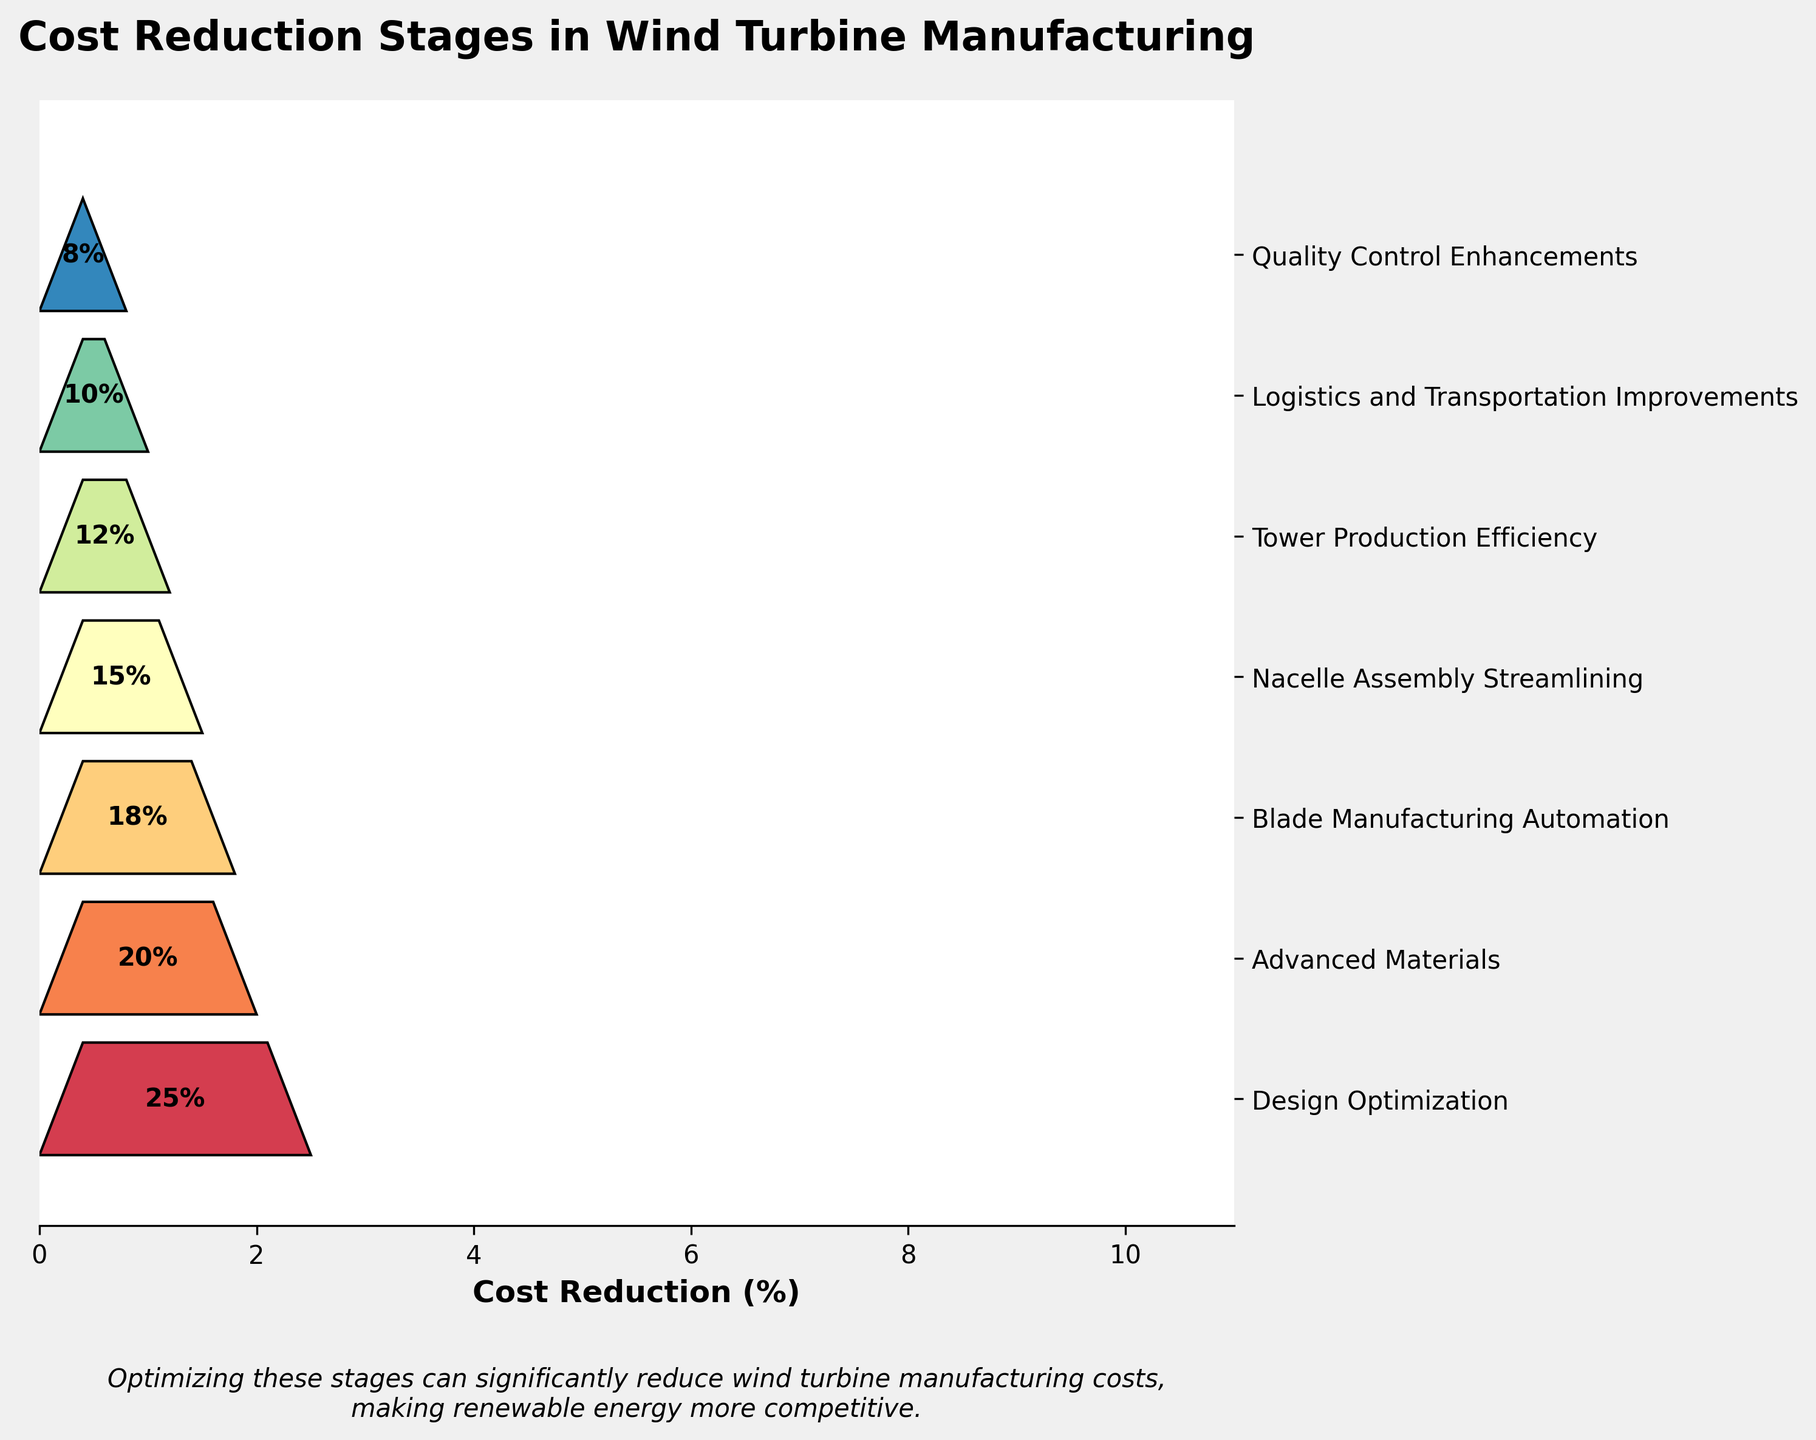What stage has the highest cost reduction percentage? The highest cost reduction is at the "Design Optimization" stage, which is visibly the longest bar with the most percentage written in the figure.
Answer: Design Optimization Which stage contributes the least to cost reduction? The "Quality Control Enhancements" stage has the lowest cost reduction percentage, as indicated by the smallest bar and the smallest percentage figure.
Answer: Quality Control Enhancements What is the total cost reduction achieved by the first three stages? The first three stages are "Design Optimization" (25%), "Advanced Materials" (20%), and "Blade Manufacturing Automation" (18%). Summing these gives 25% + 20% + 18% = 63%.
Answer: 63% Which two stages have the closest cost reduction percentages? "Blade Manufacturing Automation" and "Nacelle Assembly Streamlining" have cost reductions of 18% and 15%, respectively. The difference between these two percentages is the smallest among all pairs.
Answer: Blade Manufacturing Automation and Nacelle Assembly Streamlining How does the cost reduction due to "Advanced Materials" compare to "Tower Production Efficiency"? "Advanced Materials" has a cost reduction of 20%, while "Tower Production Efficiency" has 12%. The cost reduction due to "Advanced Materials" is greater.
Answer: Advanced Materials is greater What is the combined cost reduction of the stages involved in manufacturing processes (Blade Manufacturing Automation, Nacelle Assembly Streamlining, Tower Production Efficiency)? The stages "Blade Manufacturing Automation" (18%), "Nacelle Assembly Streamlining" (15%), and "Tower Production Efficiency" (12%) sum to 18% + 15% + 12% = 45%.
Answer: 45% Which stage follows "Advanced Materials" in cost reduction? Following "Advanced Materials" (20%) is "Blade Manufacturing Automation" at 18%, as displayed on the vertical axis of the funnel chart.
Answer: Blade Manufacturing Automation How much more cost reduction is achieved by "Logistics and Transportation Improvements" compared to "Quality Control Enhancements"? "Logistics and Transportation Improvements" has a cost reduction of 10%, and "Quality Control Enhancements" has 8%. The difference is 10% - 8% = 2%.
Answer: 2% Which stage's cost reduction is closest to the total average reduction across all stages? The total cost reduction is the sum of all stages' percentages divided by the number of stages: (25% + 20% + 18% + 15% + 12% + 10% + 8%)/7 = 108% / 7 ≈ 15.43%. The "Nacelle Assembly Streamlining" stage, with 15%, is closest to this average.
Answer: Nacelle Assembly Streamlining What proportion of total cost reduction is accounted for by "Design Optimization"? The total cost reduction across all stages is 108%. The proportion for "Design Optimization" is 25 / 108 ≈ 0.231, or about 23.1%.
Answer: 23.1% 